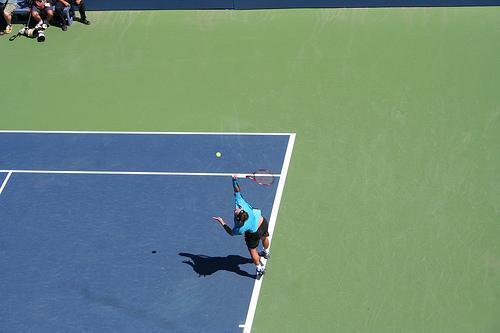How many people are in this picture?
Give a very brief answer. 4. 